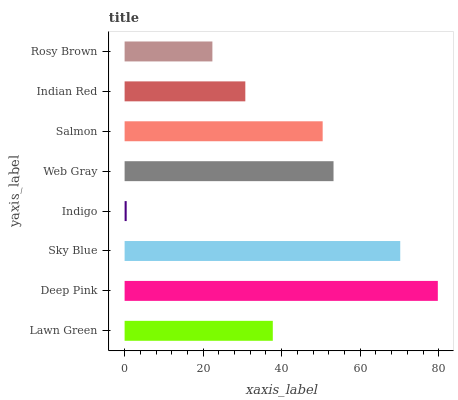Is Indigo the minimum?
Answer yes or no. Yes. Is Deep Pink the maximum?
Answer yes or no. Yes. Is Sky Blue the minimum?
Answer yes or no. No. Is Sky Blue the maximum?
Answer yes or no. No. Is Deep Pink greater than Sky Blue?
Answer yes or no. Yes. Is Sky Blue less than Deep Pink?
Answer yes or no. Yes. Is Sky Blue greater than Deep Pink?
Answer yes or no. No. Is Deep Pink less than Sky Blue?
Answer yes or no. No. Is Salmon the high median?
Answer yes or no. Yes. Is Lawn Green the low median?
Answer yes or no. Yes. Is Web Gray the high median?
Answer yes or no. No. Is Salmon the low median?
Answer yes or no. No. 